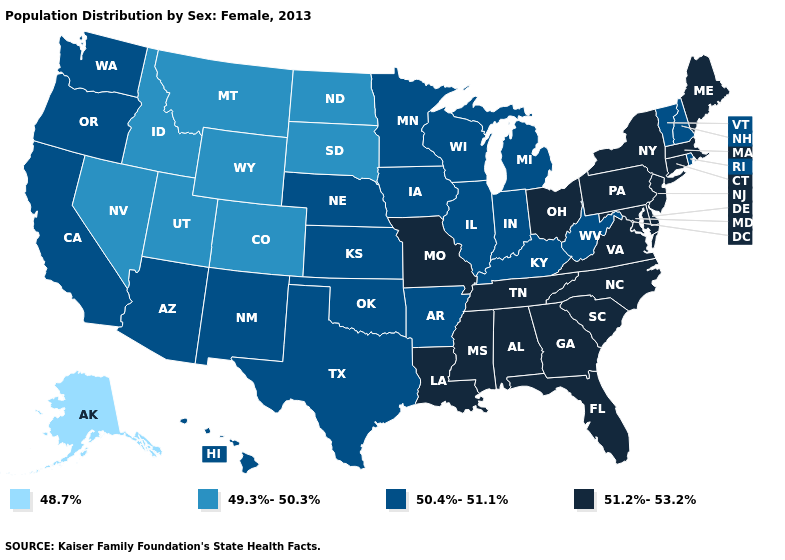Does Nevada have the highest value in the West?
Quick response, please. No. What is the value of Georgia?
Quick response, please. 51.2%-53.2%. Does Utah have the lowest value in the USA?
Short answer required. No. Which states hav the highest value in the West?
Be succinct. Arizona, California, Hawaii, New Mexico, Oregon, Washington. Which states have the lowest value in the Northeast?
Answer briefly. New Hampshire, Rhode Island, Vermont. What is the value of Texas?
Write a very short answer. 50.4%-51.1%. Name the states that have a value in the range 50.4%-51.1%?
Answer briefly. Arizona, Arkansas, California, Hawaii, Illinois, Indiana, Iowa, Kansas, Kentucky, Michigan, Minnesota, Nebraska, New Hampshire, New Mexico, Oklahoma, Oregon, Rhode Island, Texas, Vermont, Washington, West Virginia, Wisconsin. Name the states that have a value in the range 50.4%-51.1%?
Keep it brief. Arizona, Arkansas, California, Hawaii, Illinois, Indiana, Iowa, Kansas, Kentucky, Michigan, Minnesota, Nebraska, New Hampshire, New Mexico, Oklahoma, Oregon, Rhode Island, Texas, Vermont, Washington, West Virginia, Wisconsin. Does Wyoming have the highest value in the West?
Quick response, please. No. Name the states that have a value in the range 51.2%-53.2%?
Concise answer only. Alabama, Connecticut, Delaware, Florida, Georgia, Louisiana, Maine, Maryland, Massachusetts, Mississippi, Missouri, New Jersey, New York, North Carolina, Ohio, Pennsylvania, South Carolina, Tennessee, Virginia. What is the value of Massachusetts?
Be succinct. 51.2%-53.2%. 